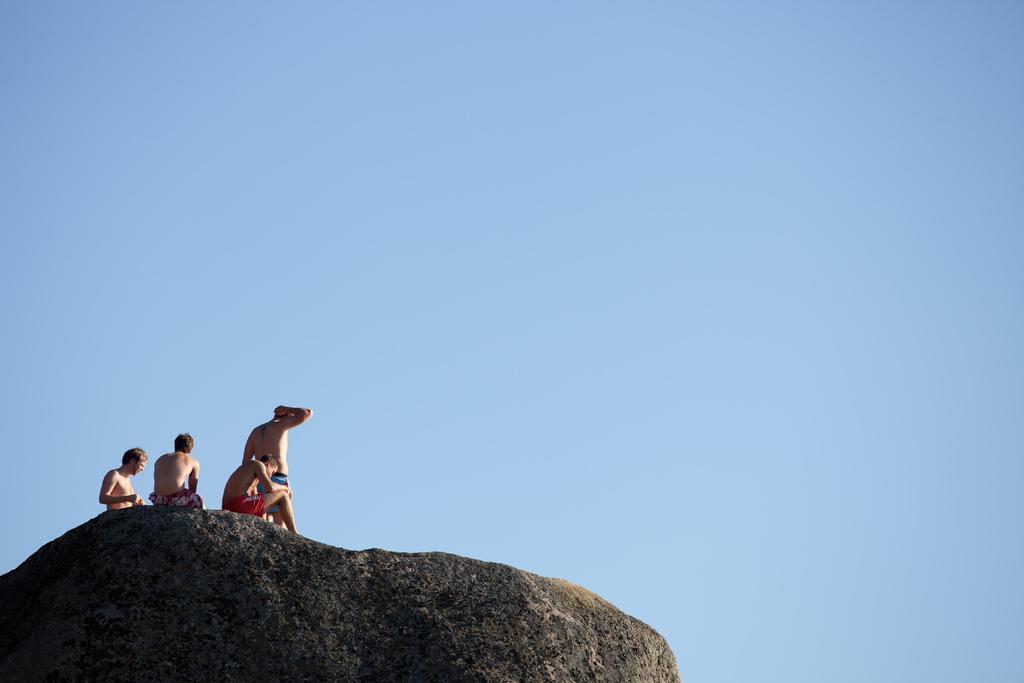Please provide a concise description of this image. In this image, at the bottom there is a stone on that there are four men. In the background there is sky. 